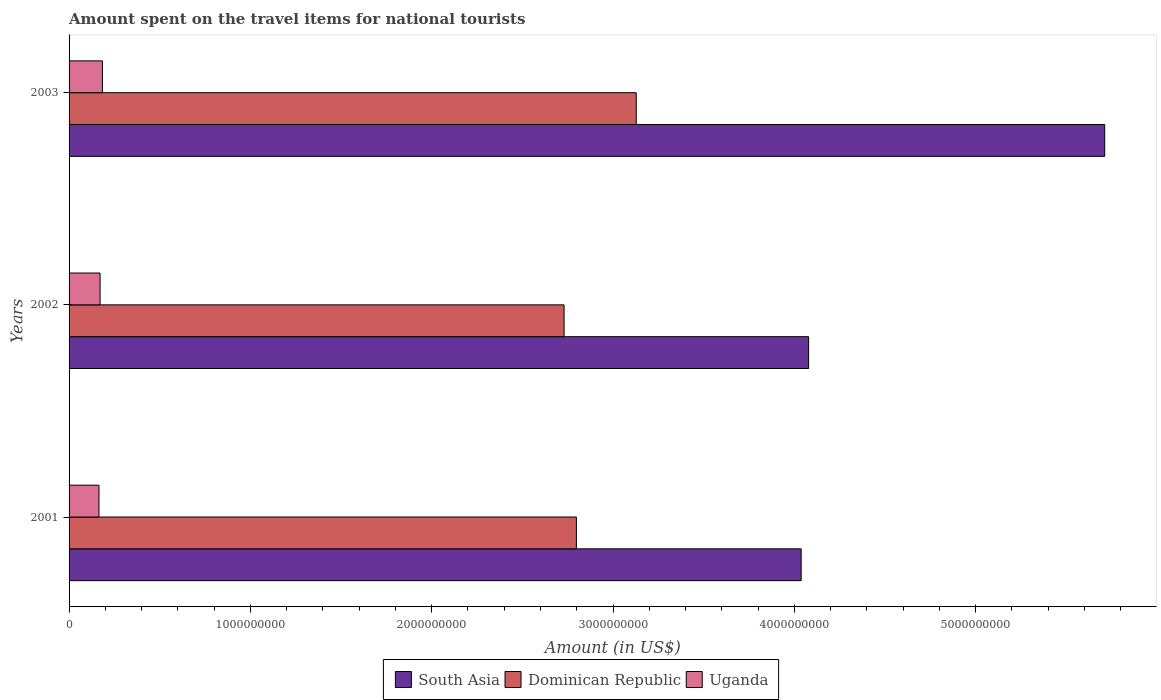How many different coloured bars are there?
Provide a short and direct response. 3. Are the number of bars on each tick of the Y-axis equal?
Offer a terse response. Yes. How many bars are there on the 2nd tick from the bottom?
Make the answer very short. 3. What is the amount spent on the travel items for national tourists in Dominican Republic in 2001?
Offer a terse response. 2.80e+09. Across all years, what is the maximum amount spent on the travel items for national tourists in Uganda?
Your answer should be very brief. 1.84e+08. Across all years, what is the minimum amount spent on the travel items for national tourists in South Asia?
Give a very brief answer. 4.04e+09. What is the total amount spent on the travel items for national tourists in Dominican Republic in the graph?
Provide a short and direct response. 8.66e+09. What is the difference between the amount spent on the travel items for national tourists in South Asia in 2001 and that in 2002?
Offer a very short reply. -4.12e+07. What is the difference between the amount spent on the travel items for national tourists in Dominican Republic in 2003 and the amount spent on the travel items for national tourists in South Asia in 2002?
Keep it short and to the point. -9.51e+08. What is the average amount spent on the travel items for national tourists in Dominican Republic per year?
Offer a terse response. 2.89e+09. In the year 2002, what is the difference between the amount spent on the travel items for national tourists in Dominican Republic and amount spent on the travel items for national tourists in South Asia?
Provide a short and direct response. -1.35e+09. What is the ratio of the amount spent on the travel items for national tourists in Dominican Republic in 2001 to that in 2002?
Give a very brief answer. 1.02. Is the amount spent on the travel items for national tourists in South Asia in 2002 less than that in 2003?
Offer a terse response. Yes. What is the difference between the highest and the second highest amount spent on the travel items for national tourists in Dominican Republic?
Give a very brief answer. 3.30e+08. What is the difference between the highest and the lowest amount spent on the travel items for national tourists in Uganda?
Your answer should be very brief. 1.90e+07. In how many years, is the amount spent on the travel items for national tourists in South Asia greater than the average amount spent on the travel items for national tourists in South Asia taken over all years?
Make the answer very short. 1. Is the sum of the amount spent on the travel items for national tourists in Dominican Republic in 2002 and 2003 greater than the maximum amount spent on the travel items for national tourists in Uganda across all years?
Provide a succinct answer. Yes. What does the 1st bar from the top in 2003 represents?
Provide a succinct answer. Uganda. Are all the bars in the graph horizontal?
Offer a terse response. Yes. How many years are there in the graph?
Your answer should be very brief. 3. What is the difference between two consecutive major ticks on the X-axis?
Your answer should be compact. 1.00e+09. Does the graph contain any zero values?
Your answer should be compact. No. Does the graph contain grids?
Your answer should be very brief. No. How many legend labels are there?
Ensure brevity in your answer.  3. What is the title of the graph?
Offer a very short reply. Amount spent on the travel items for national tourists. Does "Chad" appear as one of the legend labels in the graph?
Your answer should be very brief. No. What is the label or title of the Y-axis?
Make the answer very short. Years. What is the Amount (in US$) in South Asia in 2001?
Make the answer very short. 4.04e+09. What is the Amount (in US$) in Dominican Republic in 2001?
Your answer should be very brief. 2.80e+09. What is the Amount (in US$) in Uganda in 2001?
Provide a short and direct response. 1.65e+08. What is the Amount (in US$) of South Asia in 2002?
Offer a very short reply. 4.08e+09. What is the Amount (in US$) of Dominican Republic in 2002?
Offer a very short reply. 2.73e+09. What is the Amount (in US$) in Uganda in 2002?
Offer a very short reply. 1.71e+08. What is the Amount (in US$) in South Asia in 2003?
Your response must be concise. 5.71e+09. What is the Amount (in US$) in Dominican Republic in 2003?
Provide a short and direct response. 3.13e+09. What is the Amount (in US$) of Uganda in 2003?
Ensure brevity in your answer.  1.84e+08. Across all years, what is the maximum Amount (in US$) of South Asia?
Offer a terse response. 5.71e+09. Across all years, what is the maximum Amount (in US$) in Dominican Republic?
Keep it short and to the point. 3.13e+09. Across all years, what is the maximum Amount (in US$) of Uganda?
Your answer should be compact. 1.84e+08. Across all years, what is the minimum Amount (in US$) of South Asia?
Your answer should be very brief. 4.04e+09. Across all years, what is the minimum Amount (in US$) in Dominican Republic?
Keep it short and to the point. 2.73e+09. Across all years, what is the minimum Amount (in US$) of Uganda?
Offer a terse response. 1.65e+08. What is the total Amount (in US$) in South Asia in the graph?
Offer a terse response. 1.38e+1. What is the total Amount (in US$) in Dominican Republic in the graph?
Give a very brief answer. 8.66e+09. What is the total Amount (in US$) in Uganda in the graph?
Ensure brevity in your answer.  5.20e+08. What is the difference between the Amount (in US$) of South Asia in 2001 and that in 2002?
Provide a succinct answer. -4.12e+07. What is the difference between the Amount (in US$) in Dominican Republic in 2001 and that in 2002?
Your answer should be compact. 6.80e+07. What is the difference between the Amount (in US$) of Uganda in 2001 and that in 2002?
Give a very brief answer. -6.00e+06. What is the difference between the Amount (in US$) in South Asia in 2001 and that in 2003?
Keep it short and to the point. -1.67e+09. What is the difference between the Amount (in US$) of Dominican Republic in 2001 and that in 2003?
Give a very brief answer. -3.30e+08. What is the difference between the Amount (in US$) in Uganda in 2001 and that in 2003?
Your response must be concise. -1.90e+07. What is the difference between the Amount (in US$) in South Asia in 2002 and that in 2003?
Your answer should be very brief. -1.63e+09. What is the difference between the Amount (in US$) of Dominican Republic in 2002 and that in 2003?
Provide a succinct answer. -3.98e+08. What is the difference between the Amount (in US$) of Uganda in 2002 and that in 2003?
Keep it short and to the point. -1.30e+07. What is the difference between the Amount (in US$) in South Asia in 2001 and the Amount (in US$) in Dominican Republic in 2002?
Make the answer very short. 1.31e+09. What is the difference between the Amount (in US$) of South Asia in 2001 and the Amount (in US$) of Uganda in 2002?
Ensure brevity in your answer.  3.87e+09. What is the difference between the Amount (in US$) in Dominican Republic in 2001 and the Amount (in US$) in Uganda in 2002?
Offer a terse response. 2.63e+09. What is the difference between the Amount (in US$) of South Asia in 2001 and the Amount (in US$) of Dominican Republic in 2003?
Offer a very short reply. 9.09e+08. What is the difference between the Amount (in US$) in South Asia in 2001 and the Amount (in US$) in Uganda in 2003?
Offer a very short reply. 3.85e+09. What is the difference between the Amount (in US$) of Dominican Republic in 2001 and the Amount (in US$) of Uganda in 2003?
Provide a succinct answer. 2.61e+09. What is the difference between the Amount (in US$) in South Asia in 2002 and the Amount (in US$) in Dominican Republic in 2003?
Provide a short and direct response. 9.51e+08. What is the difference between the Amount (in US$) in South Asia in 2002 and the Amount (in US$) in Uganda in 2003?
Provide a succinct answer. 3.89e+09. What is the difference between the Amount (in US$) of Dominican Republic in 2002 and the Amount (in US$) of Uganda in 2003?
Give a very brief answer. 2.55e+09. What is the average Amount (in US$) in South Asia per year?
Keep it short and to the point. 4.61e+09. What is the average Amount (in US$) of Dominican Republic per year?
Your answer should be very brief. 2.89e+09. What is the average Amount (in US$) in Uganda per year?
Ensure brevity in your answer.  1.73e+08. In the year 2001, what is the difference between the Amount (in US$) in South Asia and Amount (in US$) in Dominican Republic?
Keep it short and to the point. 1.24e+09. In the year 2001, what is the difference between the Amount (in US$) in South Asia and Amount (in US$) in Uganda?
Offer a very short reply. 3.87e+09. In the year 2001, what is the difference between the Amount (in US$) in Dominican Republic and Amount (in US$) in Uganda?
Keep it short and to the point. 2.63e+09. In the year 2002, what is the difference between the Amount (in US$) of South Asia and Amount (in US$) of Dominican Republic?
Provide a succinct answer. 1.35e+09. In the year 2002, what is the difference between the Amount (in US$) in South Asia and Amount (in US$) in Uganda?
Your response must be concise. 3.91e+09. In the year 2002, what is the difference between the Amount (in US$) in Dominican Republic and Amount (in US$) in Uganda?
Give a very brief answer. 2.56e+09. In the year 2003, what is the difference between the Amount (in US$) of South Asia and Amount (in US$) of Dominican Republic?
Provide a short and direct response. 2.58e+09. In the year 2003, what is the difference between the Amount (in US$) of South Asia and Amount (in US$) of Uganda?
Provide a short and direct response. 5.53e+09. In the year 2003, what is the difference between the Amount (in US$) of Dominican Republic and Amount (in US$) of Uganda?
Your answer should be very brief. 2.94e+09. What is the ratio of the Amount (in US$) in South Asia in 2001 to that in 2002?
Provide a succinct answer. 0.99. What is the ratio of the Amount (in US$) of Dominican Republic in 2001 to that in 2002?
Your answer should be very brief. 1.02. What is the ratio of the Amount (in US$) of Uganda in 2001 to that in 2002?
Give a very brief answer. 0.96. What is the ratio of the Amount (in US$) of South Asia in 2001 to that in 2003?
Your answer should be compact. 0.71. What is the ratio of the Amount (in US$) in Dominican Republic in 2001 to that in 2003?
Make the answer very short. 0.89. What is the ratio of the Amount (in US$) of Uganda in 2001 to that in 2003?
Your answer should be very brief. 0.9. What is the ratio of the Amount (in US$) in South Asia in 2002 to that in 2003?
Offer a very short reply. 0.71. What is the ratio of the Amount (in US$) of Dominican Republic in 2002 to that in 2003?
Keep it short and to the point. 0.87. What is the ratio of the Amount (in US$) of Uganda in 2002 to that in 2003?
Your answer should be very brief. 0.93. What is the difference between the highest and the second highest Amount (in US$) of South Asia?
Your response must be concise. 1.63e+09. What is the difference between the highest and the second highest Amount (in US$) of Dominican Republic?
Provide a succinct answer. 3.30e+08. What is the difference between the highest and the second highest Amount (in US$) of Uganda?
Your answer should be very brief. 1.30e+07. What is the difference between the highest and the lowest Amount (in US$) of South Asia?
Provide a short and direct response. 1.67e+09. What is the difference between the highest and the lowest Amount (in US$) of Dominican Republic?
Your answer should be compact. 3.98e+08. What is the difference between the highest and the lowest Amount (in US$) of Uganda?
Offer a terse response. 1.90e+07. 